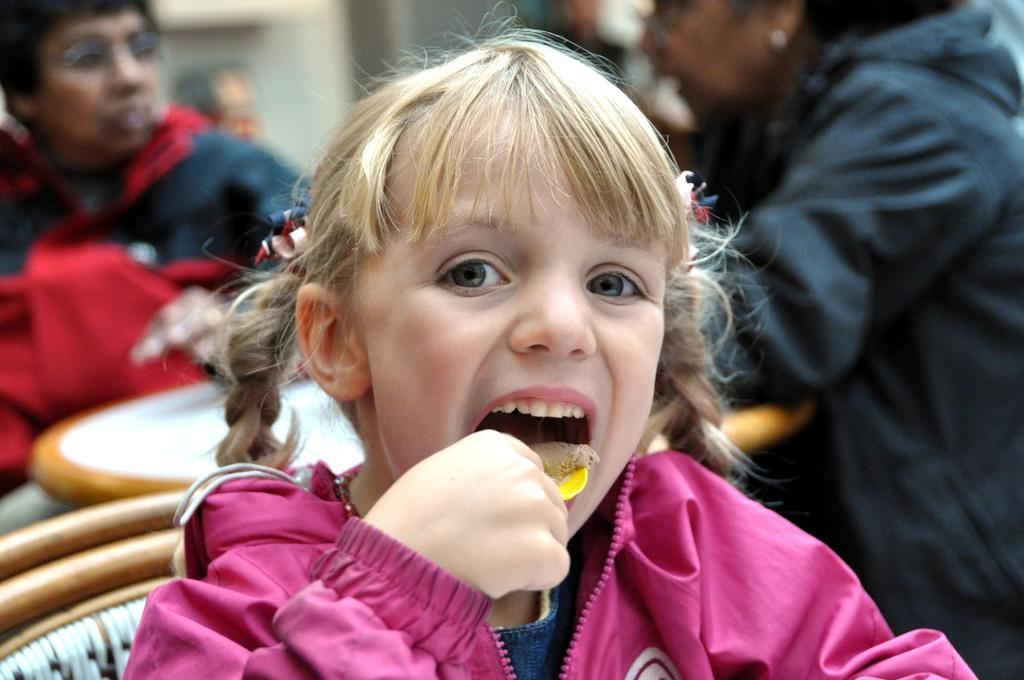Who is the main subject in the image? There is a girl in the image. What is the girl doing in the image? The girl is eating something. What furniture is present in the image? There is a chair and a table in the image. How many people are in the image? There are two persons in the image. Can you describe the background of the image? The background appears blurry. What type of volcano can be seen erupting in the background of the image? There is no volcano present in the image; the background appears blurry but does not show any volcanic activity. How fast is the crowd moving in the image? There is no crowd present in the image, so it is not possible to determine the rate at which they might be moving. 